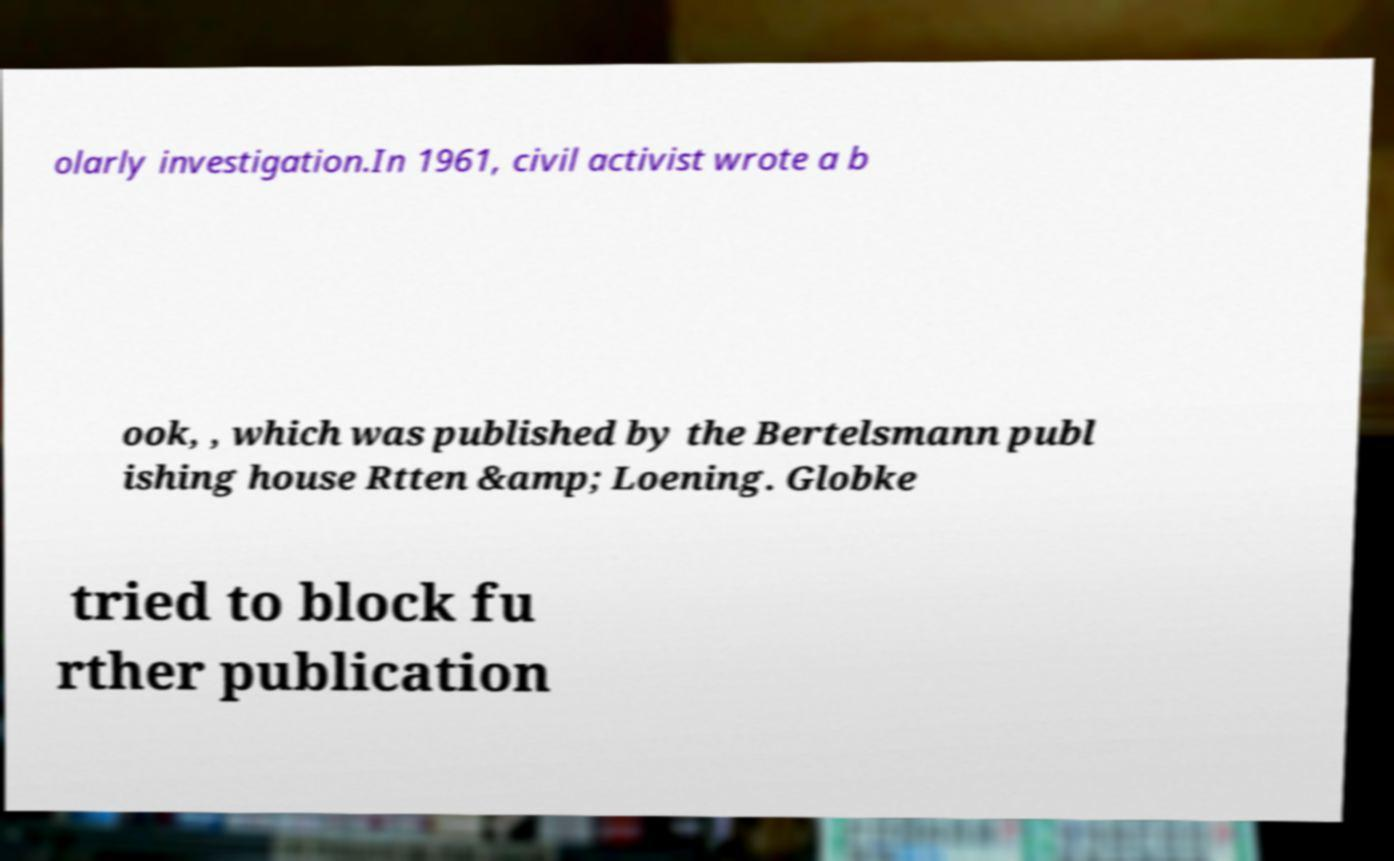Can you accurately transcribe the text from the provided image for me? olarly investigation.In 1961, civil activist wrote a b ook, , which was published by the Bertelsmann publ ishing house Rtten &amp; Loening. Globke tried to block fu rther publication 